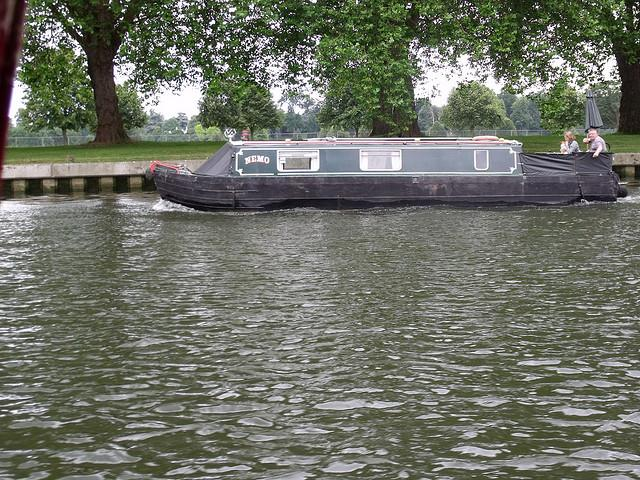What does the word on the boat relate?

Choices:
A) song
B) movie
C) bus
D) book movie 